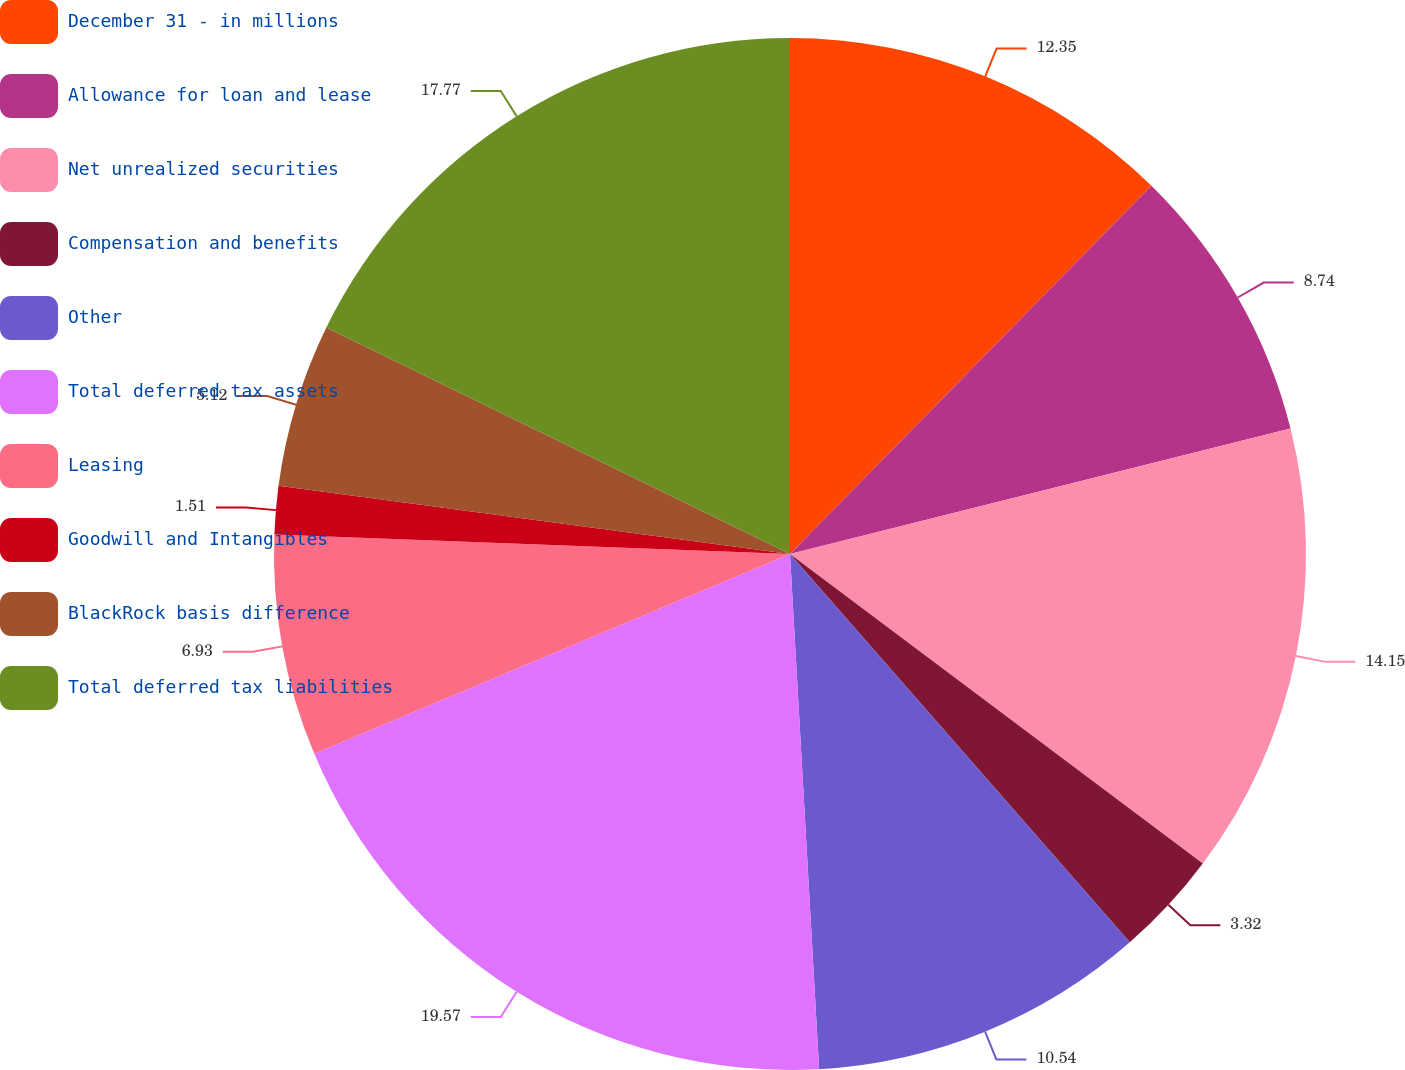<chart> <loc_0><loc_0><loc_500><loc_500><pie_chart><fcel>December 31 - in millions<fcel>Allowance for loan and lease<fcel>Net unrealized securities<fcel>Compensation and benefits<fcel>Other<fcel>Total deferred tax assets<fcel>Leasing<fcel>Goodwill and Intangibles<fcel>BlackRock basis difference<fcel>Total deferred tax liabilities<nl><fcel>12.35%<fcel>8.74%<fcel>14.15%<fcel>3.32%<fcel>10.54%<fcel>19.57%<fcel>6.93%<fcel>1.51%<fcel>5.12%<fcel>17.77%<nl></chart> 